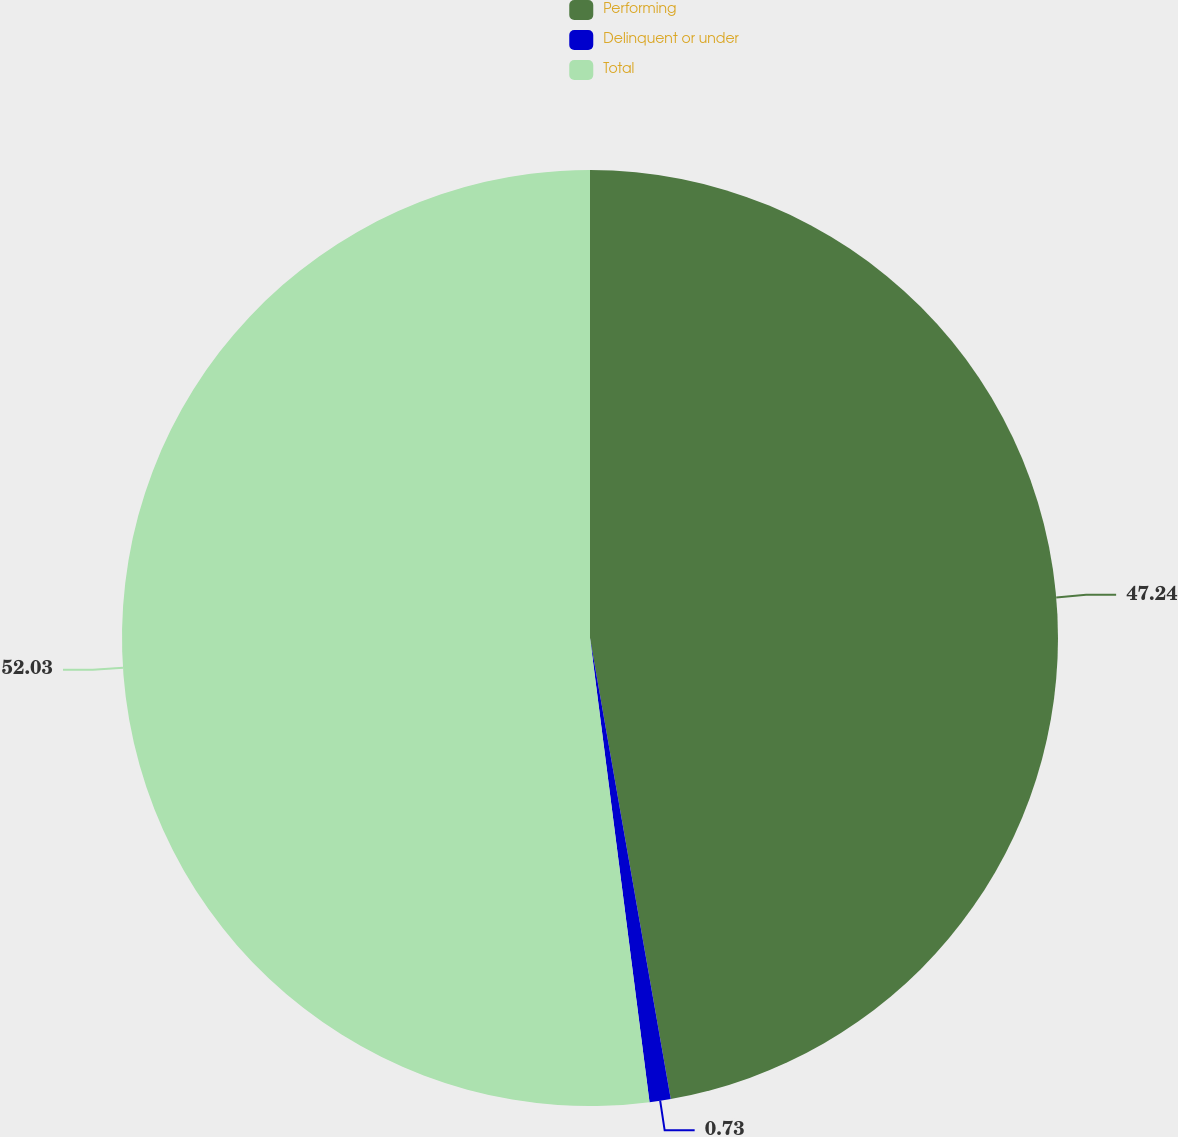<chart> <loc_0><loc_0><loc_500><loc_500><pie_chart><fcel>Performing<fcel>Delinquent or under<fcel>Total<nl><fcel>47.24%<fcel>0.73%<fcel>52.03%<nl></chart> 